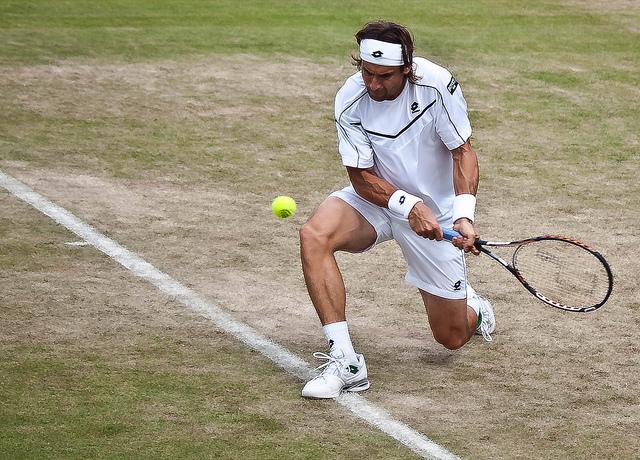Why does the grass look unhealthy?
Give a very brief answer. Too many people walking on it. Did he just hit the ball?
Concise answer only. No. What game is this?
Short answer required. Tennis. Are the players stripes going vertically or horizontally?
Short answer required. Horizontally. 